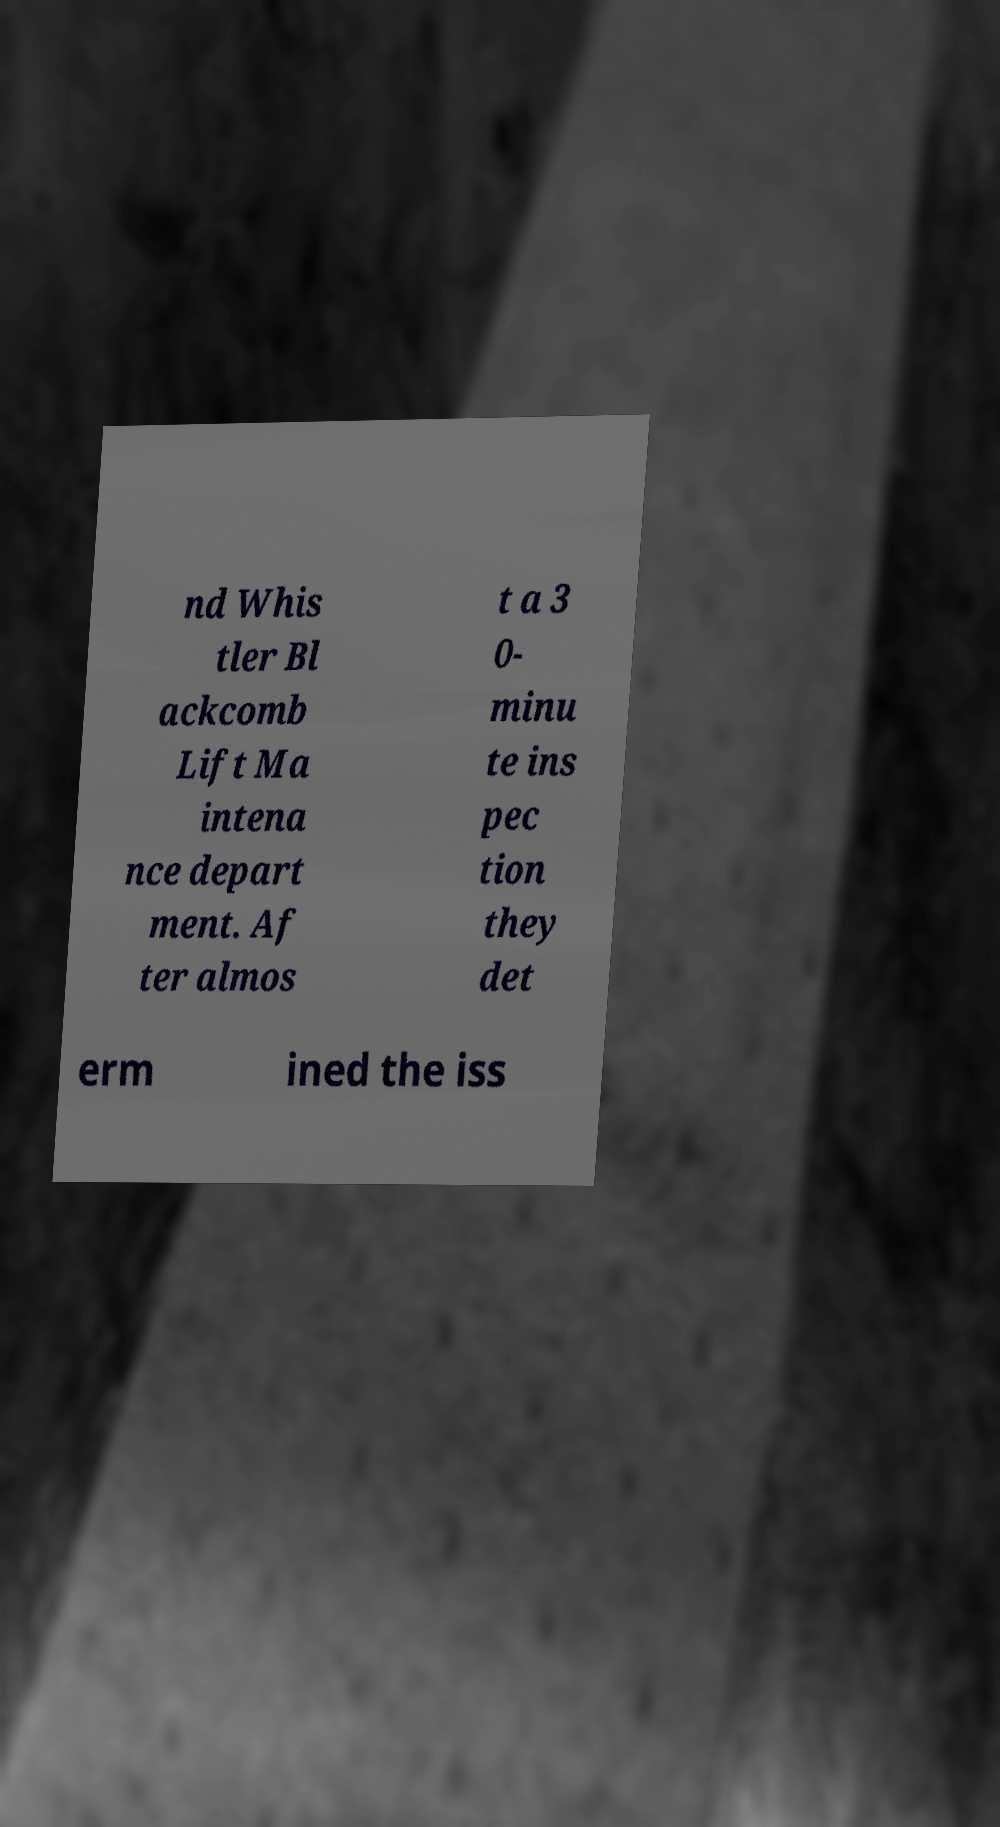Could you assist in decoding the text presented in this image and type it out clearly? nd Whis tler Bl ackcomb Lift Ma intena nce depart ment. Af ter almos t a 3 0- minu te ins pec tion they det erm ined the iss 